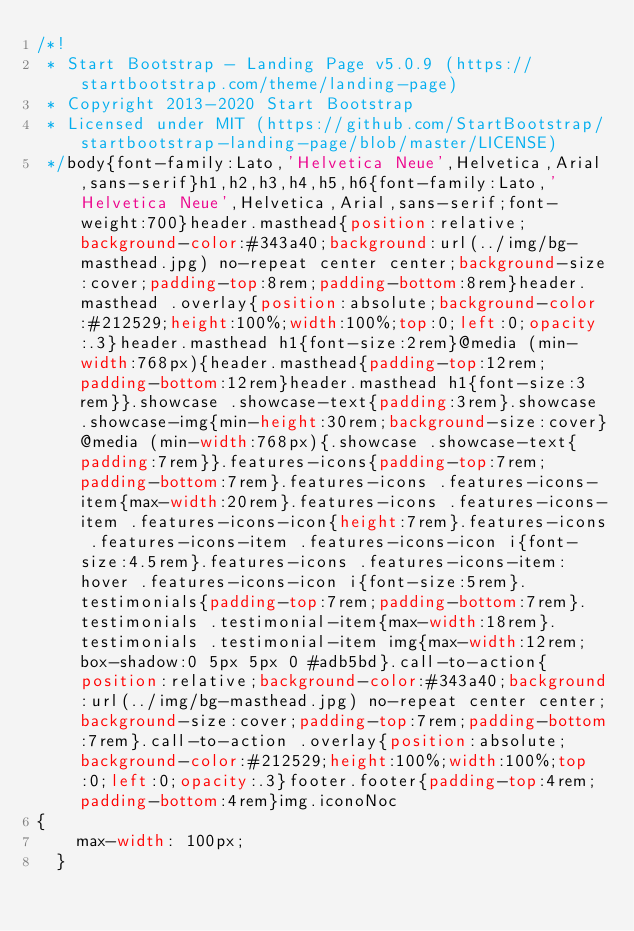Convert code to text. <code><loc_0><loc_0><loc_500><loc_500><_CSS_>/*!
 * Start Bootstrap - Landing Page v5.0.9 (https://startbootstrap.com/theme/landing-page)
 * Copyright 2013-2020 Start Bootstrap
 * Licensed under MIT (https://github.com/StartBootstrap/startbootstrap-landing-page/blob/master/LICENSE)
 */body{font-family:Lato,'Helvetica Neue',Helvetica,Arial,sans-serif}h1,h2,h3,h4,h5,h6{font-family:Lato,'Helvetica Neue',Helvetica,Arial,sans-serif;font-weight:700}header.masthead{position:relative;background-color:#343a40;background:url(../img/bg-masthead.jpg) no-repeat center center;background-size:cover;padding-top:8rem;padding-bottom:8rem}header.masthead .overlay{position:absolute;background-color:#212529;height:100%;width:100%;top:0;left:0;opacity:.3}header.masthead h1{font-size:2rem}@media (min-width:768px){header.masthead{padding-top:12rem;padding-bottom:12rem}header.masthead h1{font-size:3rem}}.showcase .showcase-text{padding:3rem}.showcase .showcase-img{min-height:30rem;background-size:cover}@media (min-width:768px){.showcase .showcase-text{padding:7rem}}.features-icons{padding-top:7rem;padding-bottom:7rem}.features-icons .features-icons-item{max-width:20rem}.features-icons .features-icons-item .features-icons-icon{height:7rem}.features-icons .features-icons-item .features-icons-icon i{font-size:4.5rem}.features-icons .features-icons-item:hover .features-icons-icon i{font-size:5rem}.testimonials{padding-top:7rem;padding-bottom:7rem}.testimonials .testimonial-item{max-width:18rem}.testimonials .testimonial-item img{max-width:12rem;box-shadow:0 5px 5px 0 #adb5bd}.call-to-action{position:relative;background-color:#343a40;background:url(../img/bg-masthead.jpg) no-repeat center center;background-size:cover;padding-top:7rem;padding-bottom:7rem}.call-to-action .overlay{position:absolute;background-color:#212529;height:100%;width:100%;top:0;left:0;opacity:.3}footer.footer{padding-top:4rem;padding-bottom:4rem}img.iconoNoc
{
    max-width: 100px;
  }</code> 